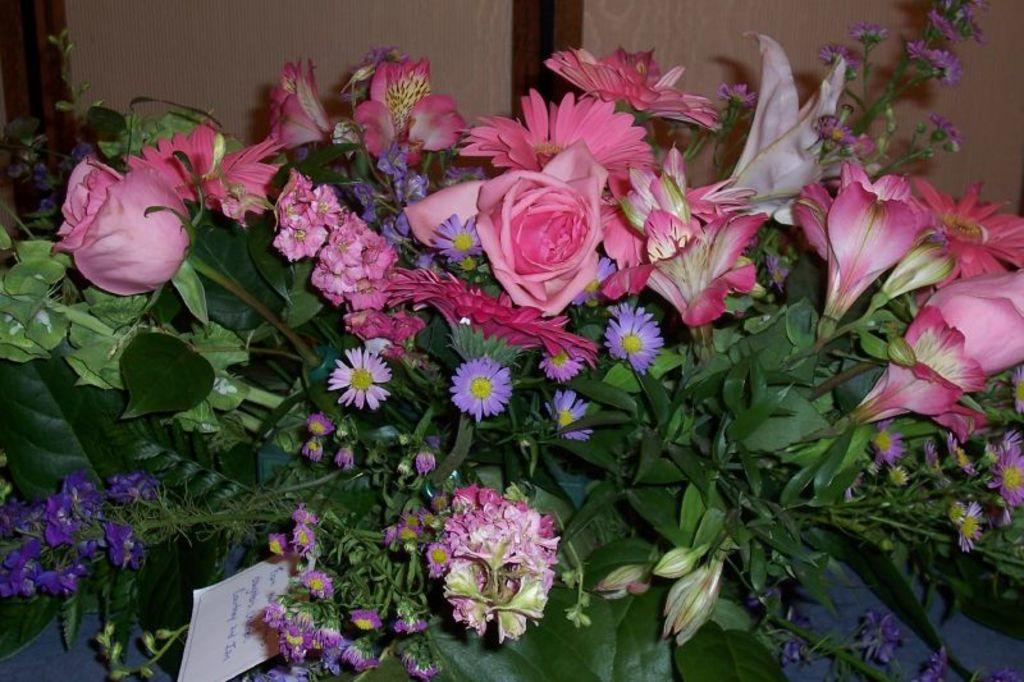What types of plants can be seen in the image? There are different types of flowers on the plants in the image. Can you describe any other features in the image besides the plants? Yes, there is a door visible at the back of the image. What beliefs do the flowers in the image hold? Flowers do not hold beliefs, as they are inanimate objects. 